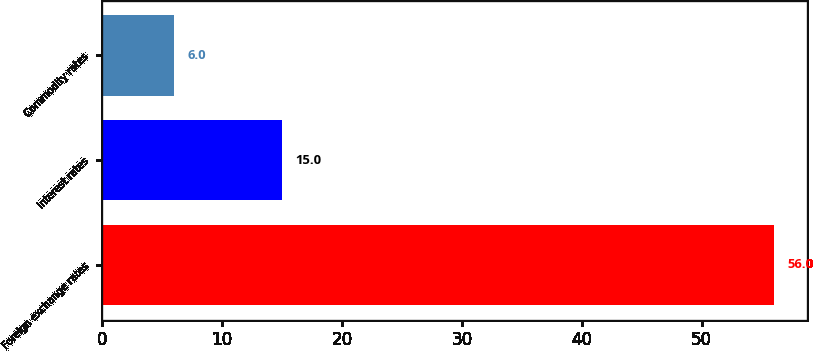Convert chart. <chart><loc_0><loc_0><loc_500><loc_500><bar_chart><fcel>Foreign exchange rates<fcel>Interest rates<fcel>Commodity rates<nl><fcel>56<fcel>15<fcel>6<nl></chart> 